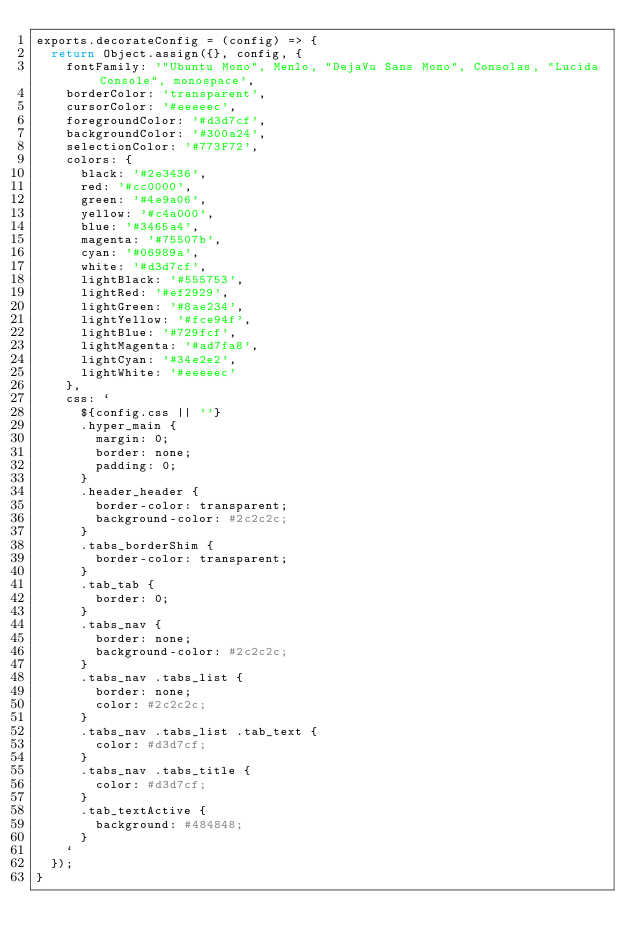Convert code to text. <code><loc_0><loc_0><loc_500><loc_500><_JavaScript_>exports.decorateConfig = (config) => {
  return Object.assign({}, config, {
    fontFamily: '"Ubuntu Mono", Menlo, "DejaVu Sans Mono", Consolas, "Lucida Console", monospace',
    borderColor: 'transparent',
    cursorColor: '#eeeeec',
    foregroundColor: '#d3d7cf',
    backgroundColor: '#300a24',
    selectionColor: '#773F72',
    colors: {
      black: '#2e3436',
      red: '#cc0000',
      green: '#4e9a06',
      yellow: '#c4a000',
      blue: '#3465a4',
      magenta: '#75507b',
      cyan: '#06989a',
      white: '#d3d7cf',
      lightBlack: '#555753',
      lightRed: '#ef2929',
      lightGreen: '#8ae234',
      lightYellow: '#fce94f',
      lightBlue: '#729fcf',
      lightMagenta: '#ad7fa8',
      lightCyan: '#34e2e2',
      lightWhite: '#eeeeec'
    },
    css: `
      ${config.css || ''}
      .hyper_main {
        margin: 0;
        border: none;
        padding: 0;
      }
      .header_header {
        border-color: transparent;
        background-color: #2c2c2c;
      }
      .tabs_borderShim {
        border-color: transparent;
      }
      .tab_tab {
        border: 0;
      }
      .tabs_nav {
        border: none;
        background-color: #2c2c2c;
      }
      .tabs_nav .tabs_list {
        border: none;
        color: #2c2c2c;
      }
      .tabs_nav .tabs_list .tab_text {
        color: #d3d7cf;
      }
      .tabs_nav .tabs_title {
        color: #d3d7cf;
      }
      .tab_textActive {
        background: #484848;
      }
    `
  });
}
</code> 